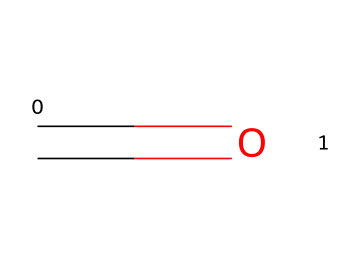What is the molecular formula of this compound? The SMILES representation shows one carbon (C) atom and one oxygen (O) atom, which combines to give the molecular formula CH2O.
Answer: CH2O How many bonds are present in this molecule? There is a double bond between the carbon and the oxygen atom in the given structure, so there is a single double bond in this molecule.
Answer: 1 What is the functional group of this chemical? The presence of a carbonyl group (C=O) in the structure identifies it as an aldehyde, which is the functional group present in this chemical.
Answer: aldehyde Is this chemical considered hazardous? Yes, formaldehyde is recognized as a hazardous chemical and is classified as a human carcinogen, which indicates its potential risks.
Answer: Yes What occurs when formaldehyde is exposed to air? Formaldehyde can readily react with air, specifically oxygen, leading to oxidation processes and the formation of various products like formic acid.
Answer: Oxidation Does this compound have a sweet odor? No, formaldehyde is known for its strong pungent and irritating odor rather than a sweet pleasant smell, which is a characteristic of many other organic compounds.
Answer: No Is this chemical soluble in water? Yes, formaldehyde (as a small molecule) is highly soluble in water, allowing it to form a solution known as formalin, often used in various applications.
Answer: Yes 